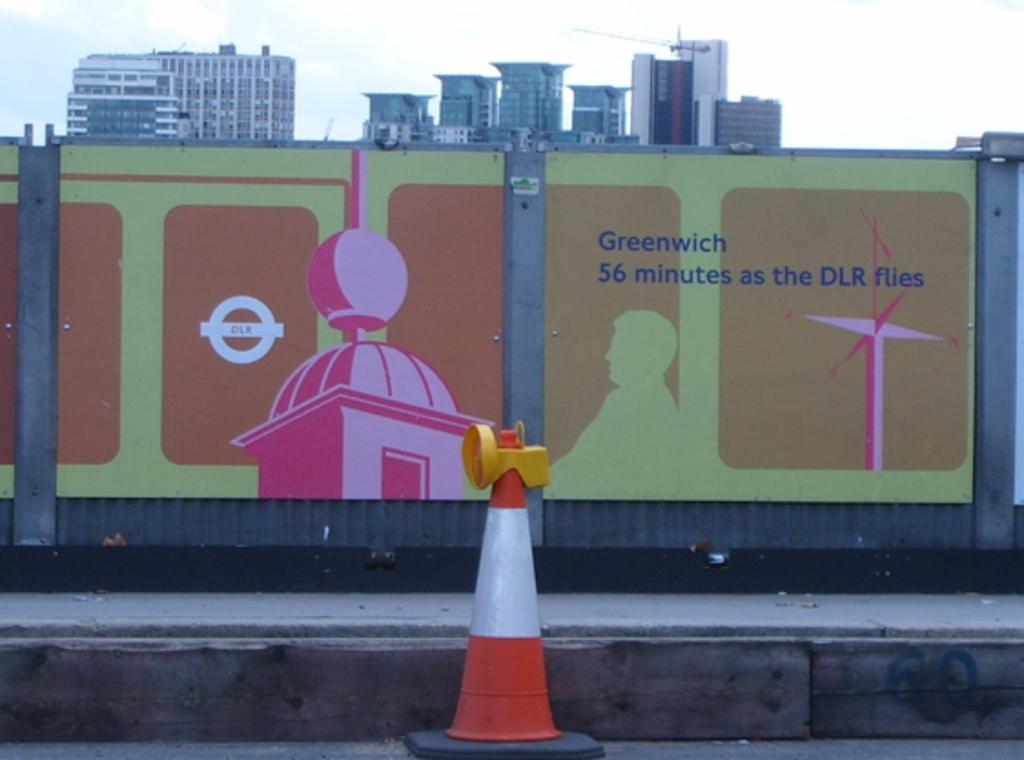How long will it take to get to greenwich?
Provide a short and direct response. 56 minutes. Where is this advertising say it is going?
Keep it short and to the point. Greenwich. 